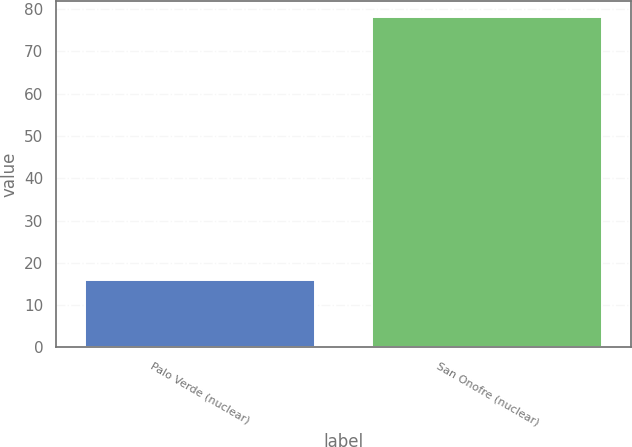<chart> <loc_0><loc_0><loc_500><loc_500><bar_chart><fcel>Palo Verde (nuclear)<fcel>San Onofre (nuclear)<nl><fcel>16<fcel>78<nl></chart> 